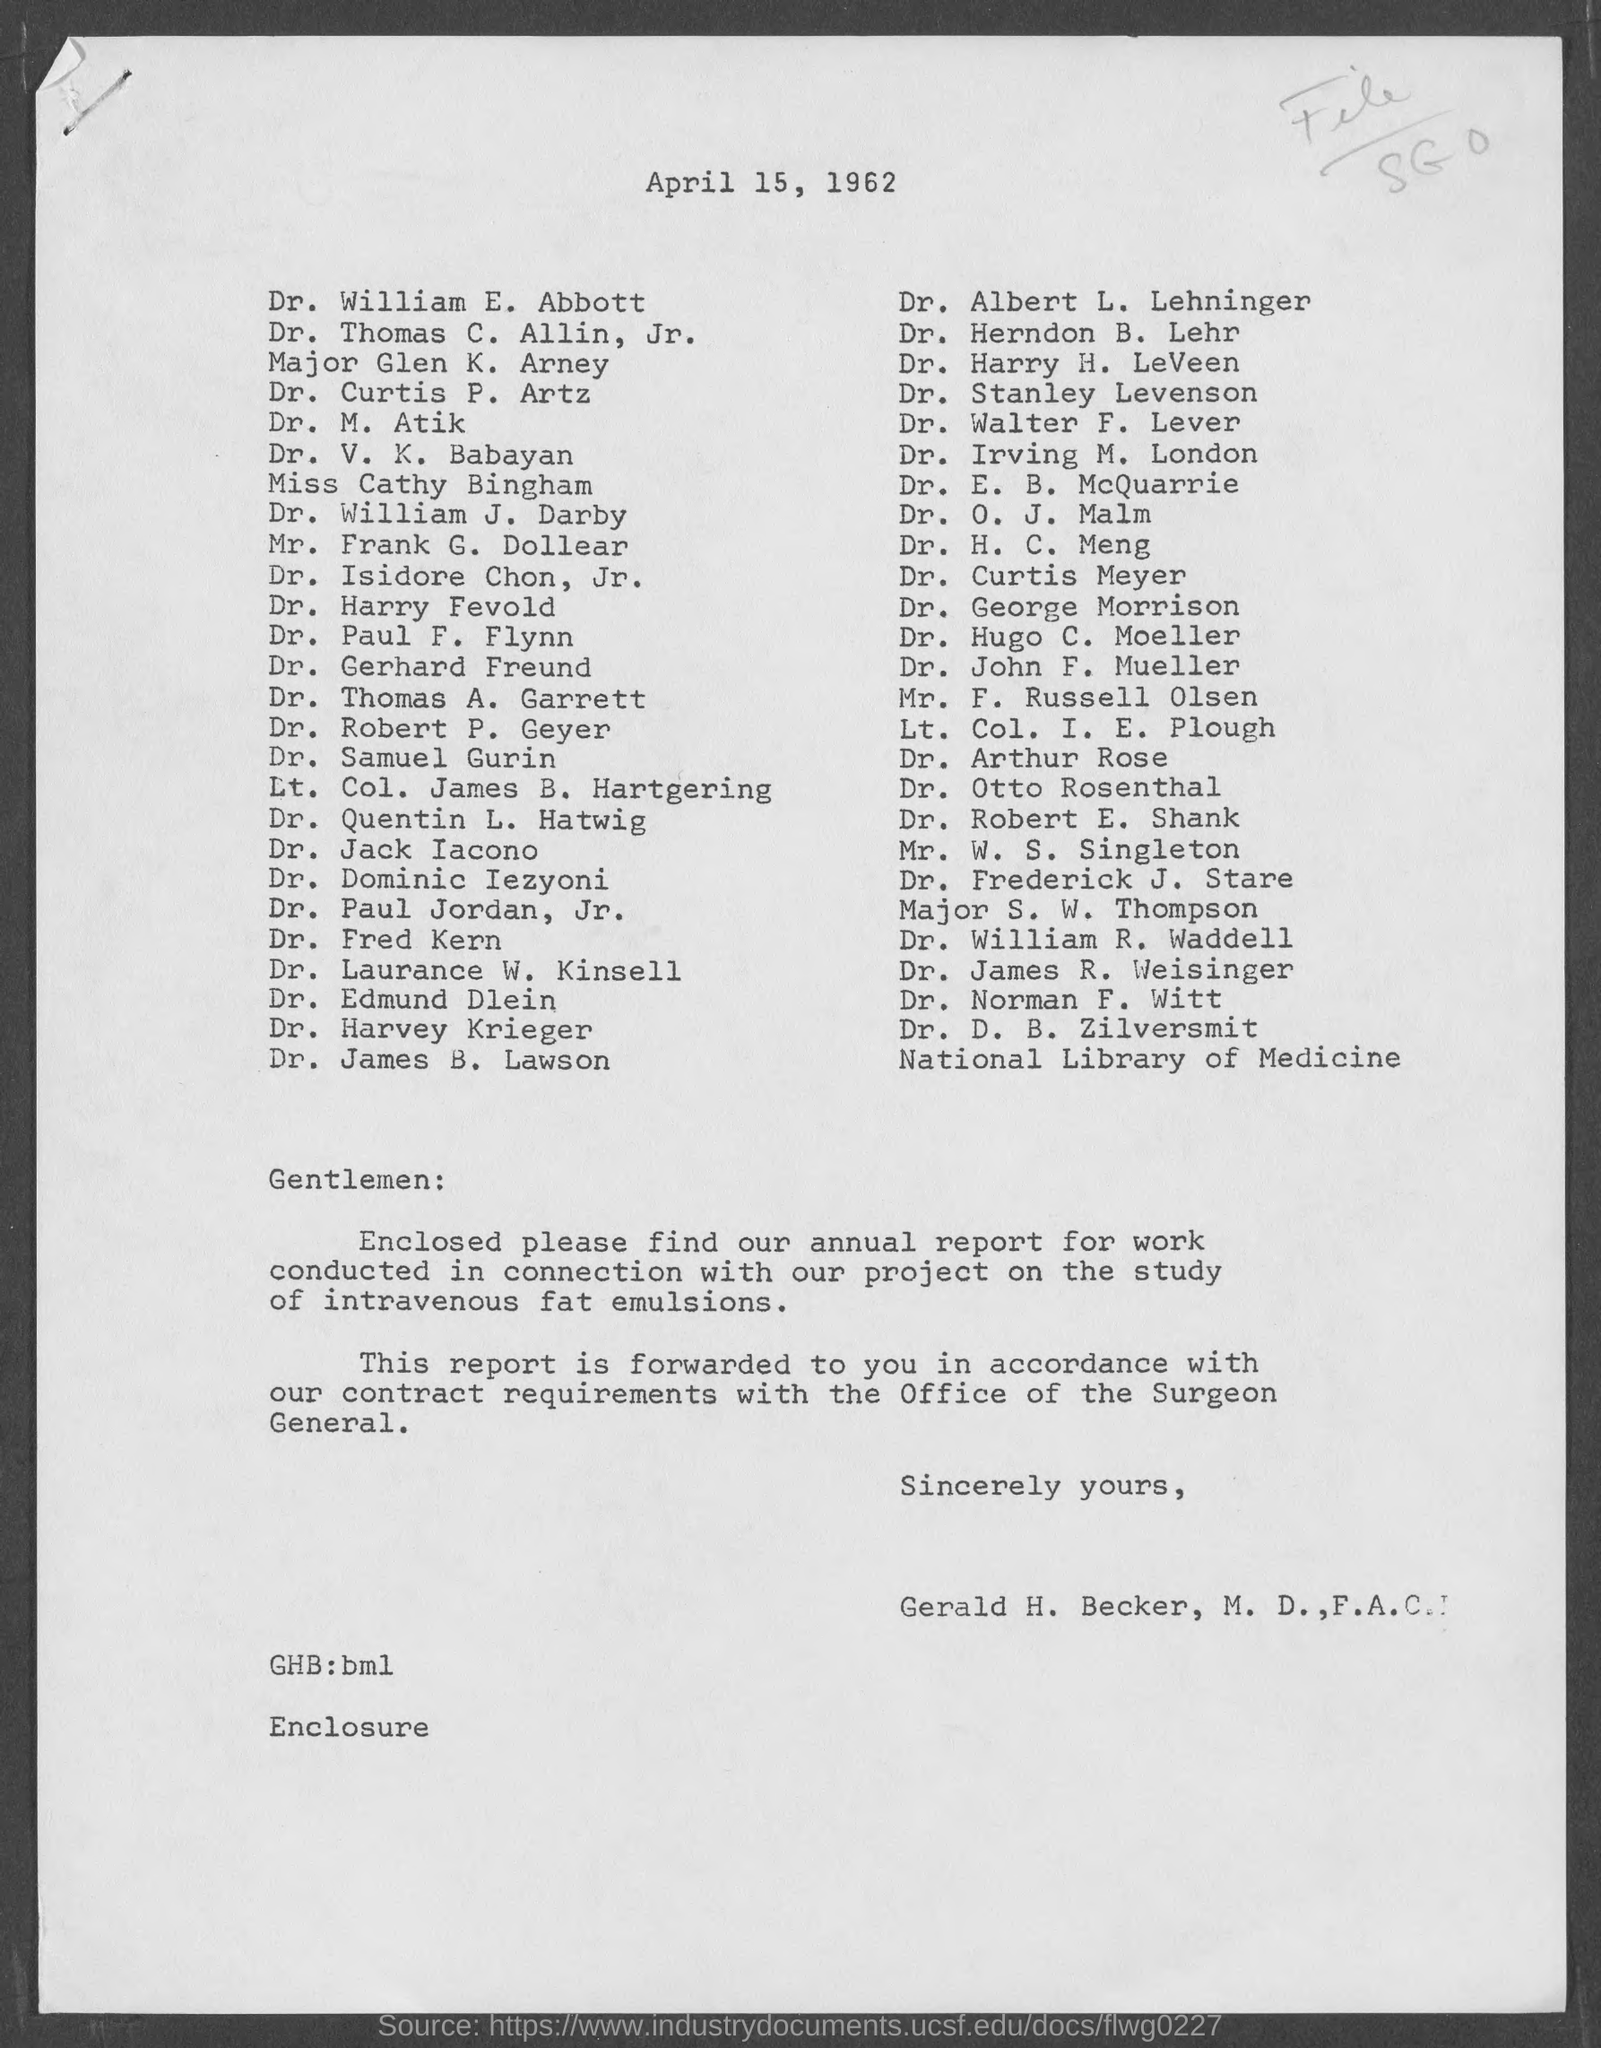What is the date?
Keep it short and to the point. April 15, 1962. What is the salutation of this letter?
Provide a short and direct response. Gentlemen:. 